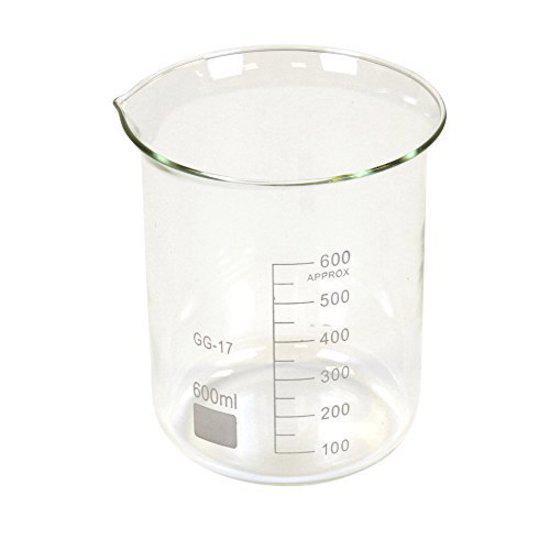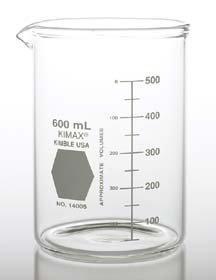The first image is the image on the left, the second image is the image on the right. Evaluate the accuracy of this statement regarding the images: "The left and right image contains the same number of full beakers.". Is it true? Answer yes or no. No. The first image is the image on the left, the second image is the image on the right. Assess this claim about the two images: "One beaker is filled with blue liquid, and one beaker is filled with reddish liquid.". Correct or not? Answer yes or no. No. 